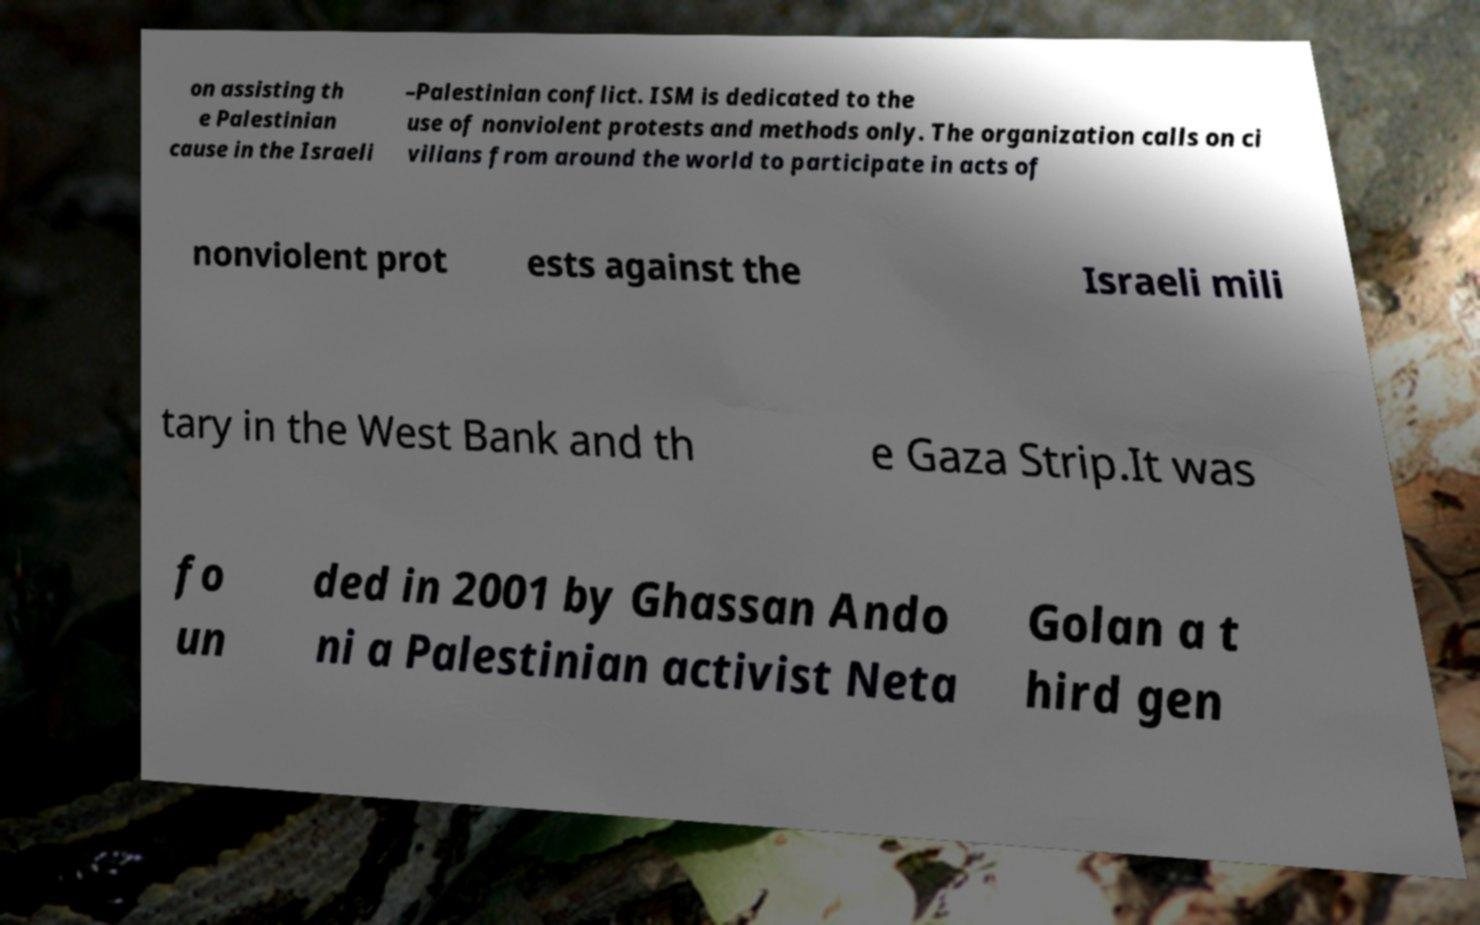Please identify and transcribe the text found in this image. on assisting th e Palestinian cause in the Israeli –Palestinian conflict. ISM is dedicated to the use of nonviolent protests and methods only. The organization calls on ci vilians from around the world to participate in acts of nonviolent prot ests against the Israeli mili tary in the West Bank and th e Gaza Strip.It was fo un ded in 2001 by Ghassan Ando ni a Palestinian activist Neta Golan a t hird gen 